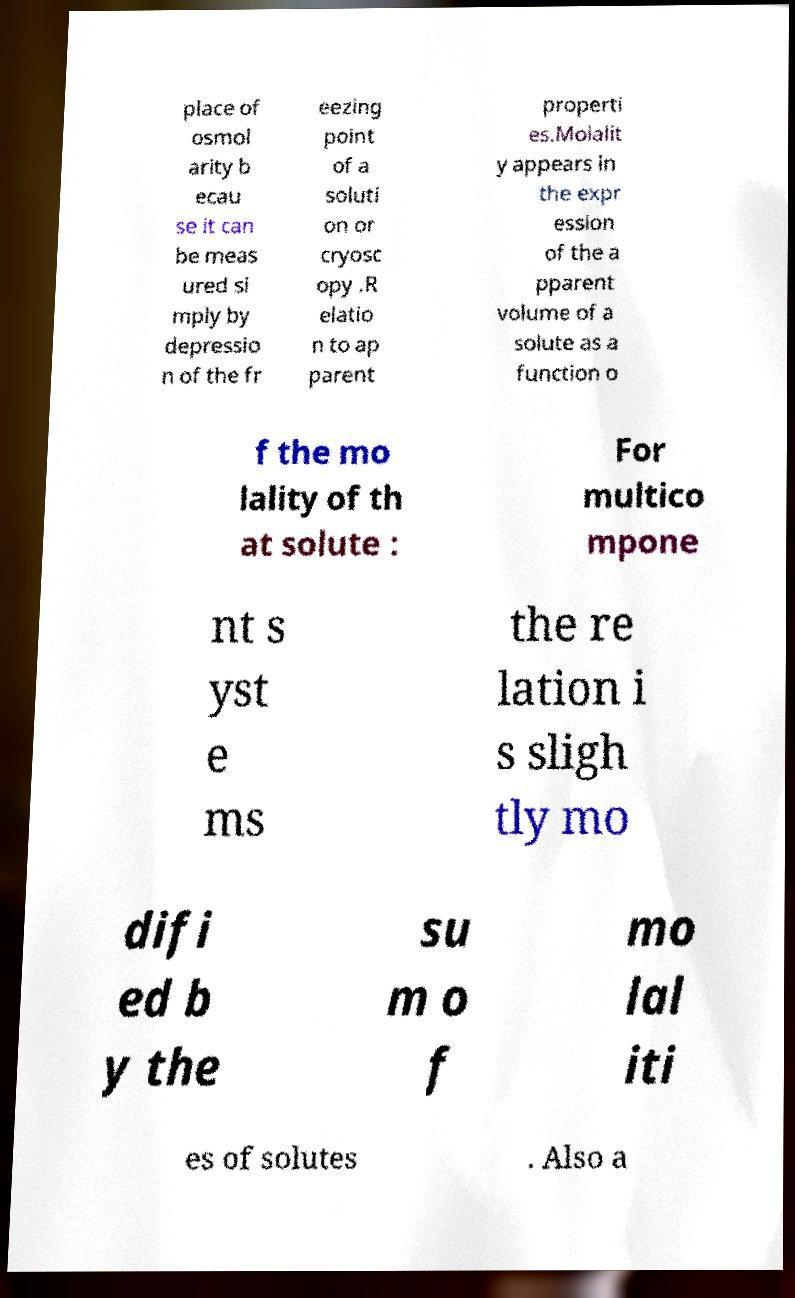For documentation purposes, I need the text within this image transcribed. Could you provide that? place of osmol arity b ecau se it can be meas ured si mply by depressio n of the fr eezing point of a soluti on or cryosc opy .R elatio n to ap parent properti es.Molalit y appears in the expr ession of the a pparent volume of a solute as a function o f the mo lality of th at solute : For multico mpone nt s yst e ms the re lation i s sligh tly mo difi ed b y the su m o f mo lal iti es of solutes . Also a 